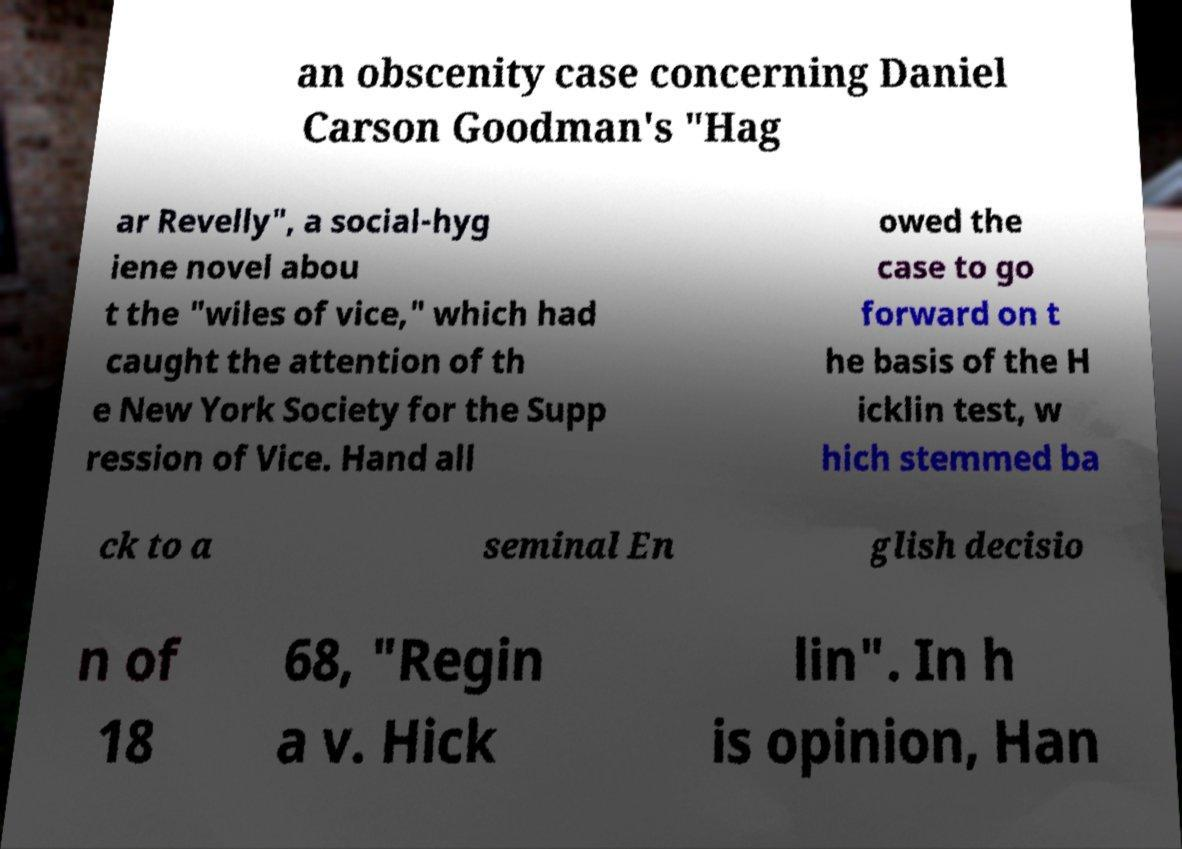Can you accurately transcribe the text from the provided image for me? an obscenity case concerning Daniel Carson Goodman's "Hag ar Revelly", a social-hyg iene novel abou t the "wiles of vice," which had caught the attention of th e New York Society for the Supp ression of Vice. Hand all owed the case to go forward on t he basis of the H icklin test, w hich stemmed ba ck to a seminal En glish decisio n of 18 68, "Regin a v. Hick lin". In h is opinion, Han 